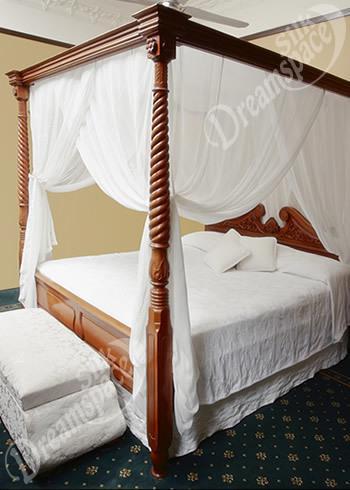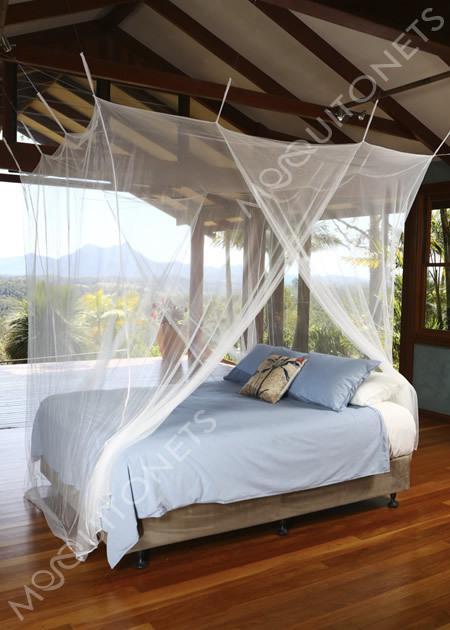The first image is the image on the left, the second image is the image on the right. Evaluate the accuracy of this statement regarding the images: "One of the beds has a wooden frame.". Is it true? Answer yes or no. Yes. 